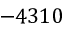<formula> <loc_0><loc_0><loc_500><loc_500>- 4 3 1 0</formula> 